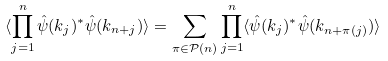<formula> <loc_0><loc_0><loc_500><loc_500>\langle \prod ^ { n } _ { j = 1 } \hat { \psi } ( k _ { j } ) ^ { \ast } \hat { \psi } ( k _ { n + j } ) \rangle = \sum _ { \pi \in \mathcal { P } ( n ) } \prod ^ { n } _ { j = 1 } \langle \hat { \psi } ( k _ { j } ) ^ { \ast } \hat { \psi } ( k _ { n + \pi ( j ) } ) \rangle \,</formula> 